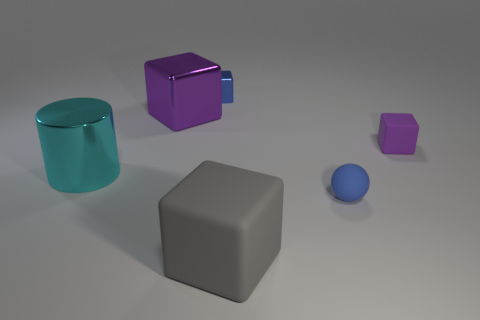Subtract 1 cubes. How many cubes are left? 3 Add 2 large rubber cubes. How many objects exist? 8 Subtract all green cubes. Subtract all green spheres. How many cubes are left? 4 Subtract all blocks. How many objects are left? 2 Subtract all cyan matte objects. Subtract all small matte things. How many objects are left? 4 Add 2 small purple matte cubes. How many small purple matte cubes are left? 3 Add 6 small purple blocks. How many small purple blocks exist? 7 Subtract 0 purple cylinders. How many objects are left? 6 